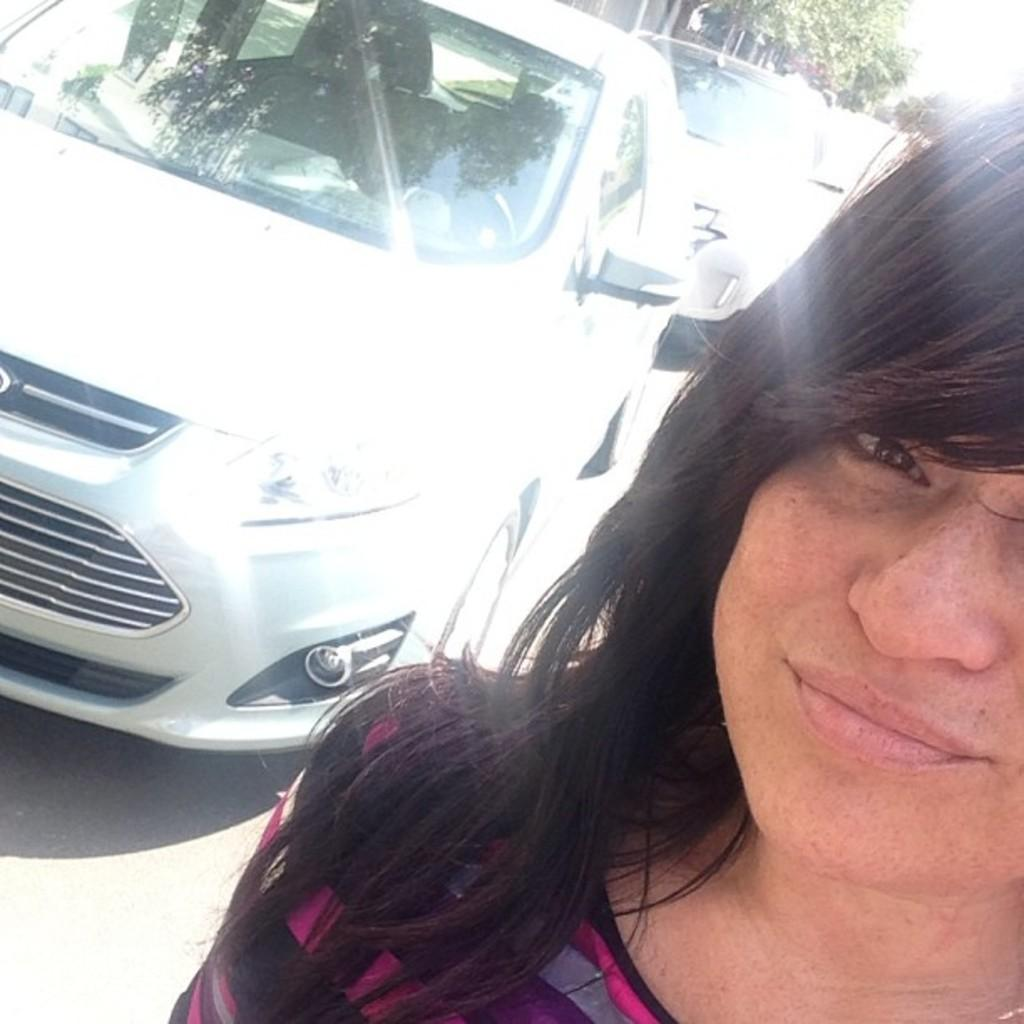Who or what is located on the right side of the image? There is a person on the right side of the image. What can be seen on the left side of the image? There are vehicles on the road on the left side of the image. What type of natural elements are visible at the top right hand side of the image? There are trees visible at the top right hand side of the image. What type of secretary can be seen working in the image? There is no secretary present in the image. What type of support is the person on the right side of the image providing to the vehicles on the road? The person on the right side of the image is not providing any support to the vehicles on the road, as they are separate entities in the image. 